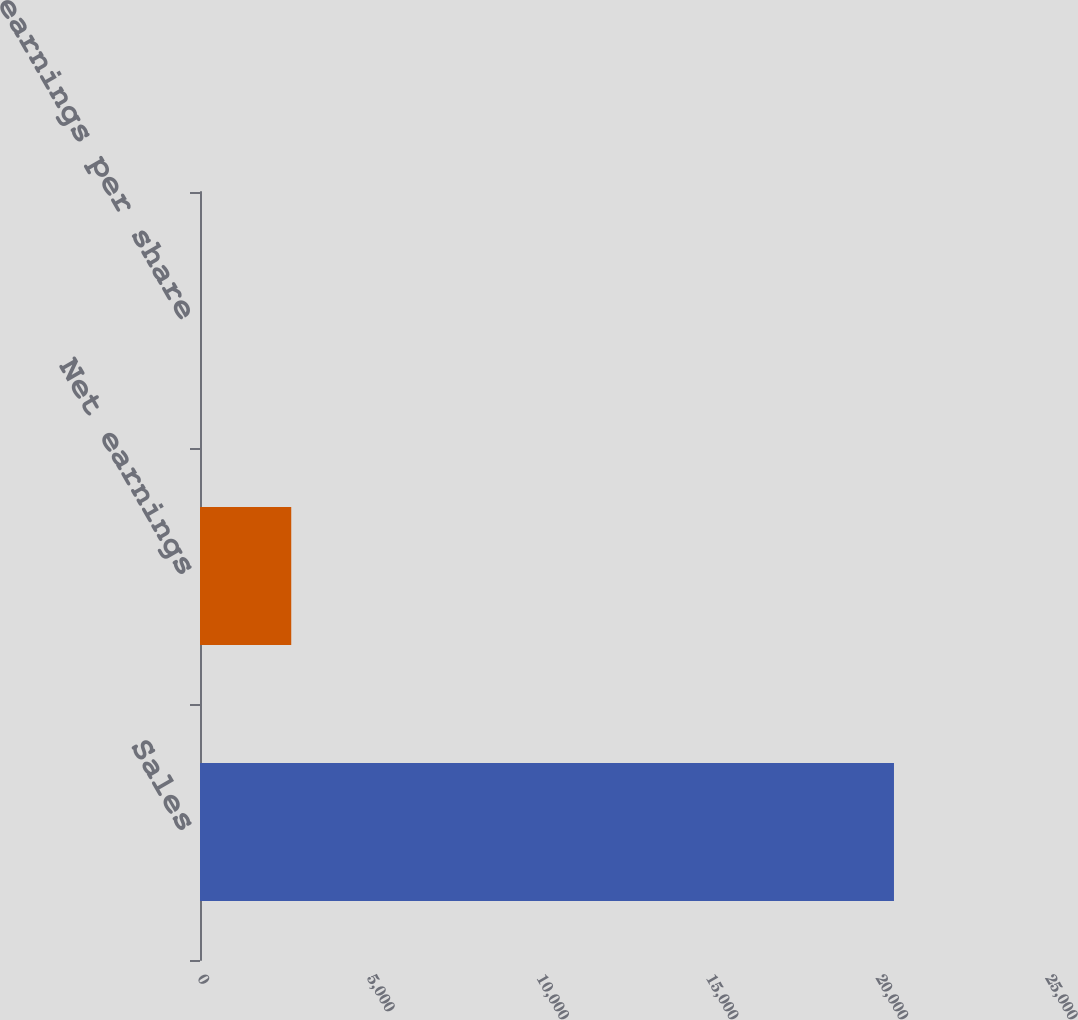Convert chart. <chart><loc_0><loc_0><loc_500><loc_500><bar_chart><fcel>Sales<fcel>Net earnings<fcel>Diluted net earnings per share<nl><fcel>20459.2<fcel>2689.9<fcel>3.79<nl></chart> 